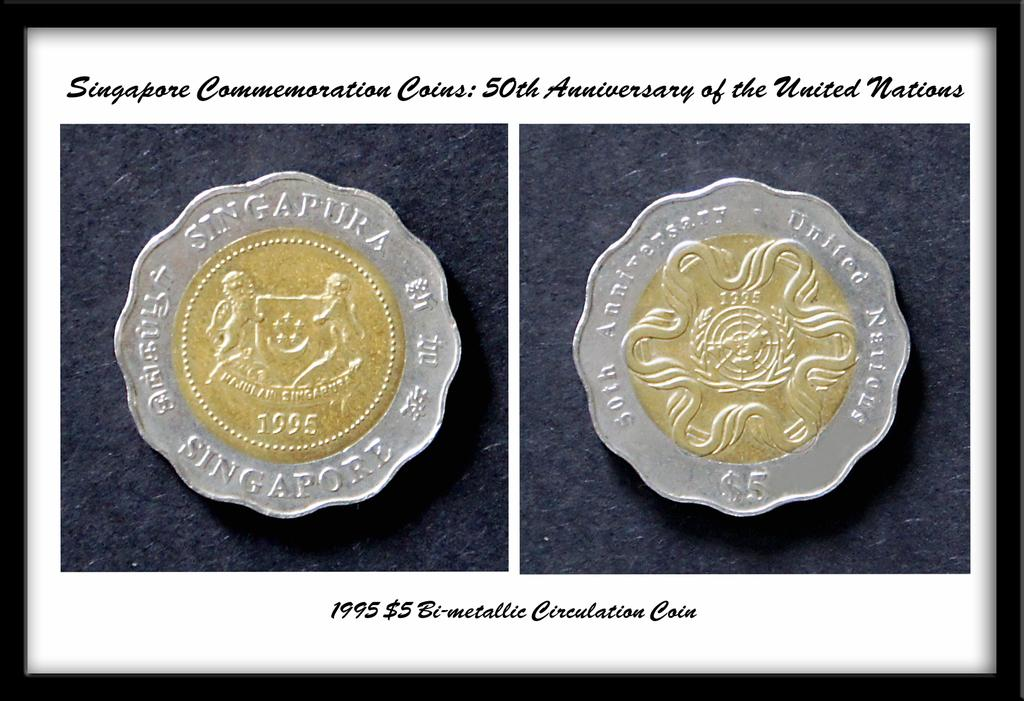<image>
Provide a brief description of the given image. Two framed coins from Singapore commemorating the 50th Anniversary of the United Nations 